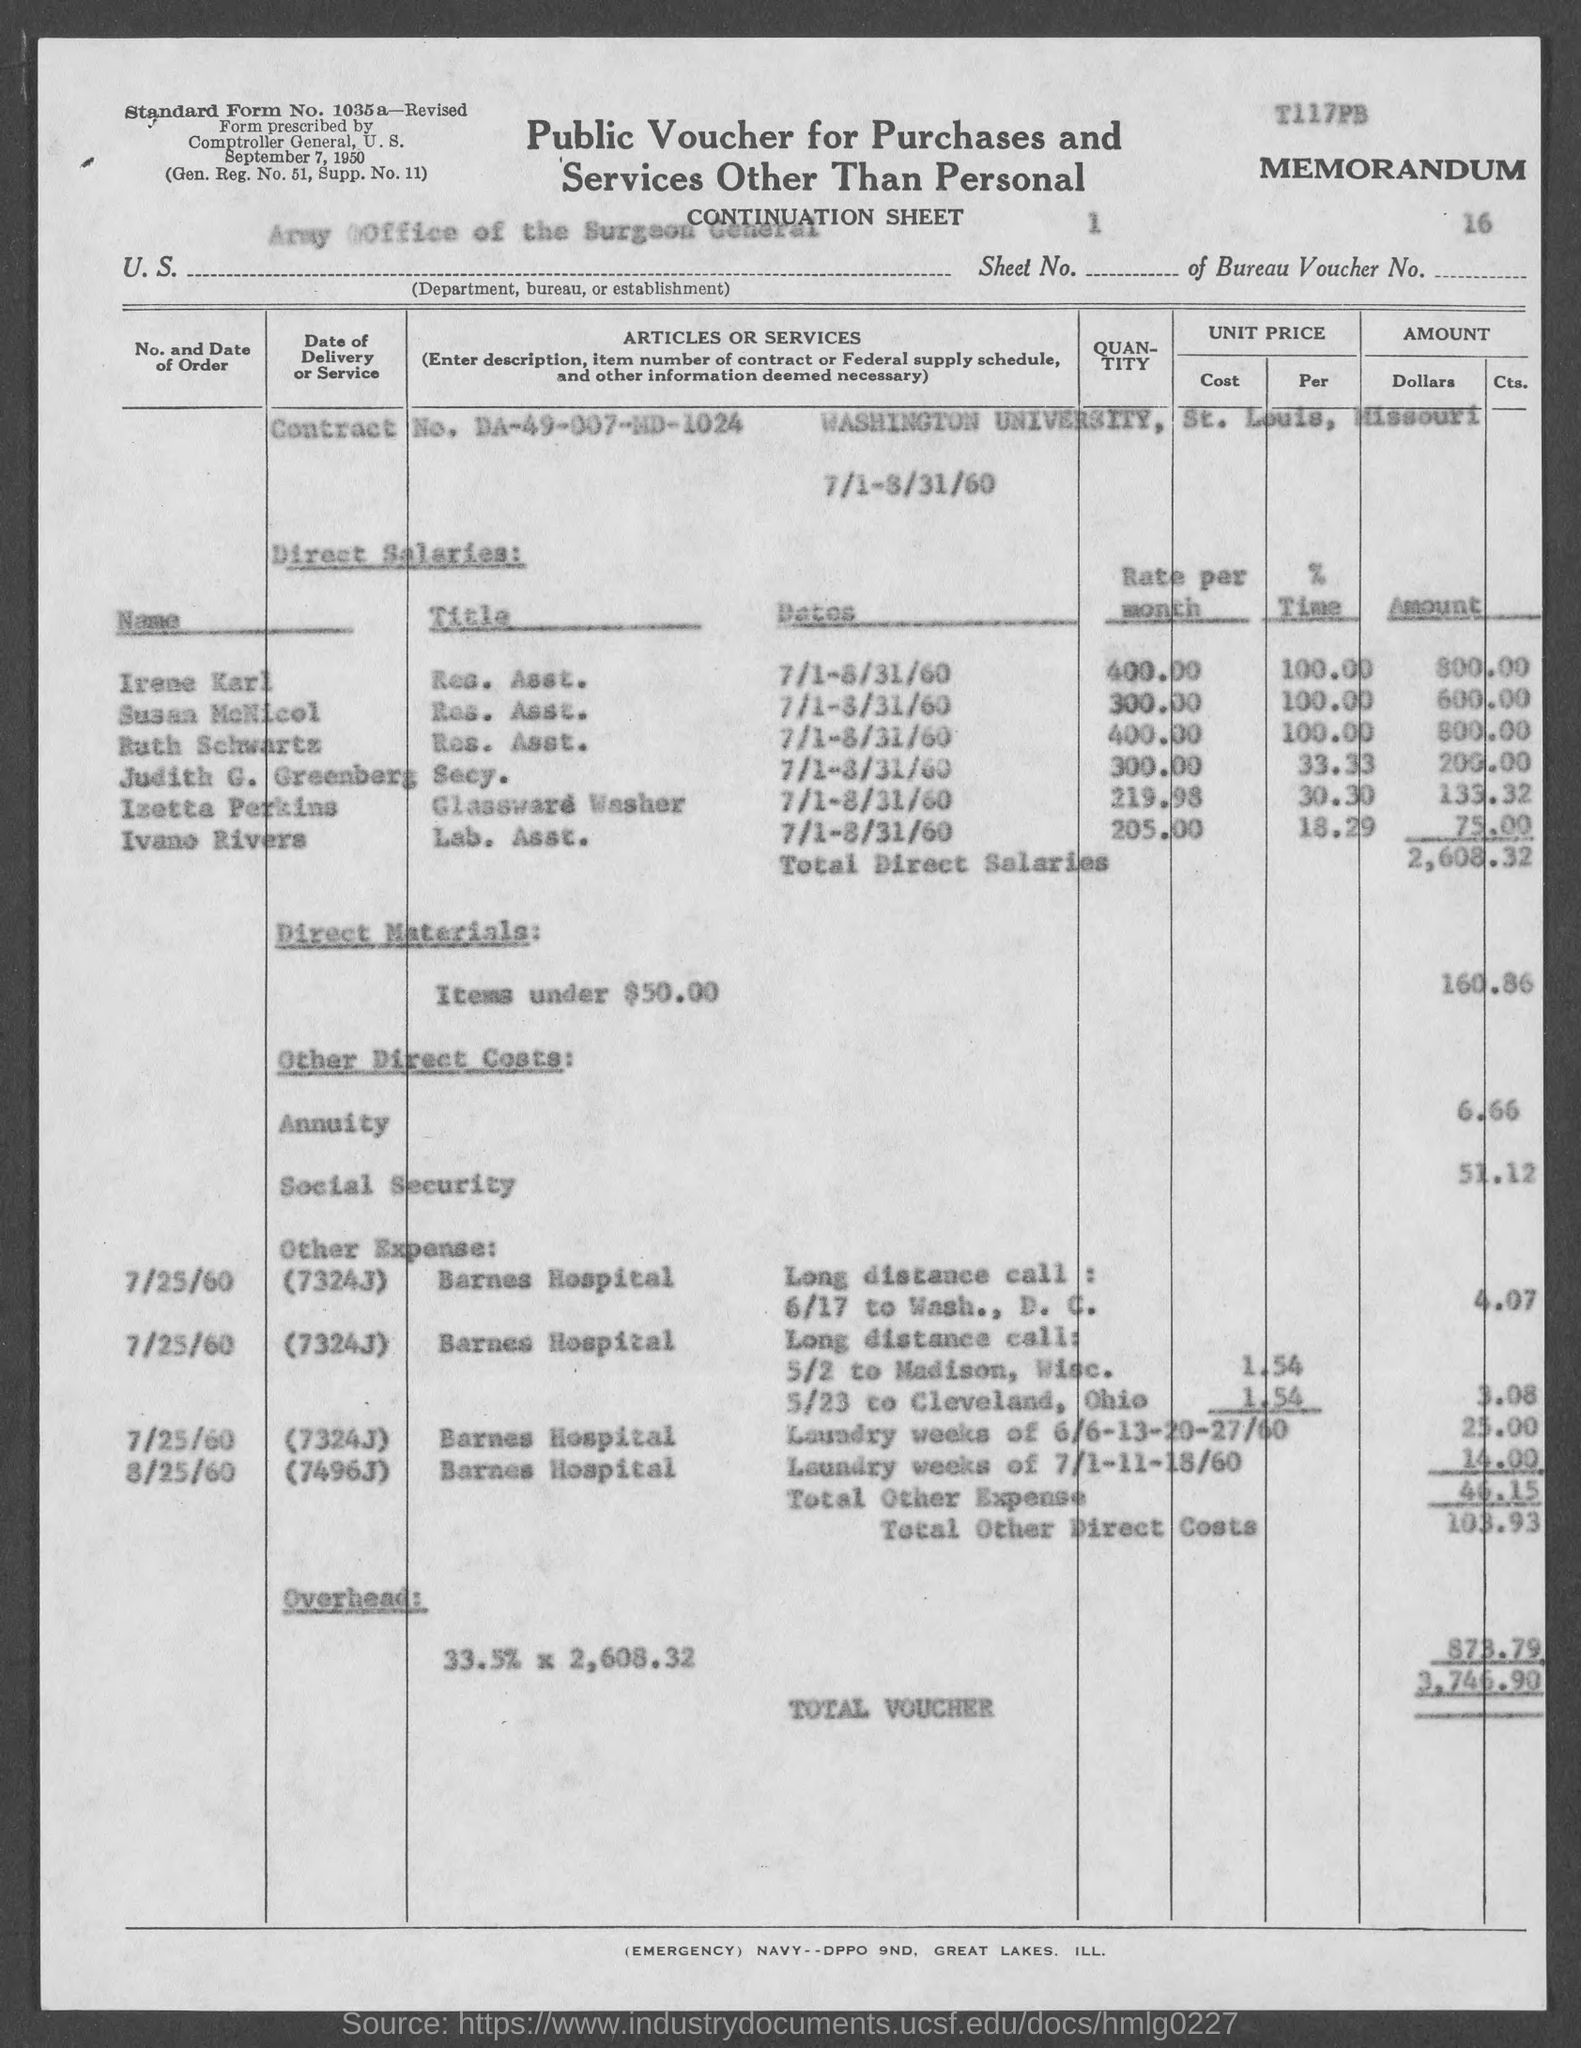What is the contract no. mentioned in the given form ?
Provide a succinct answer. DA-49-007-MD-1024. What is the bureau voucher no. mentioned in the given form ?
Provide a succinct answer. 16. What is the amount of total direct salaries mentioned in the given page ?
Your response must be concise. 2,608.32. What is the amount of direct materials mentioned in the given page ?
Your answer should be compact. 160.86. What is the amount for annuity as mentioned in the given form ?
Your response must be concise. 6.66. What is the amount for social security as mentioned in the given form ?
Your answer should be very brief. 51.12. What is the amount for overhead mentioned in the given form ?
Offer a very short reply. 873.79. What is the amount of total voucher as mentioned in the given form ?
Offer a very short reply. 3,746.90. What is the sheet no. mentioned in the given form ?
Give a very brief answer. 1. 